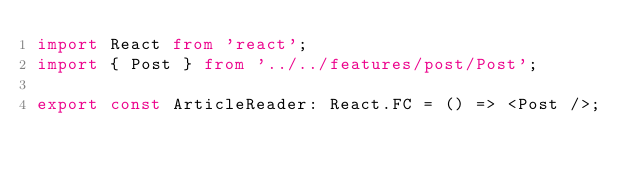<code> <loc_0><loc_0><loc_500><loc_500><_TypeScript_>import React from 'react';
import { Post } from '../../features/post/Post';

export const ArticleReader: React.FC = () => <Post />;
</code> 